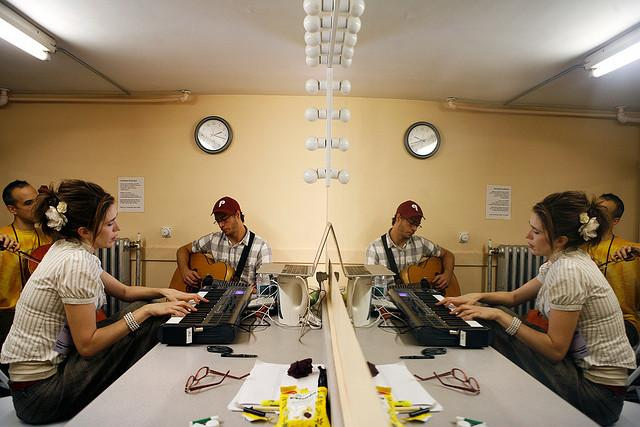At least how many musicians play different instruments here? three 